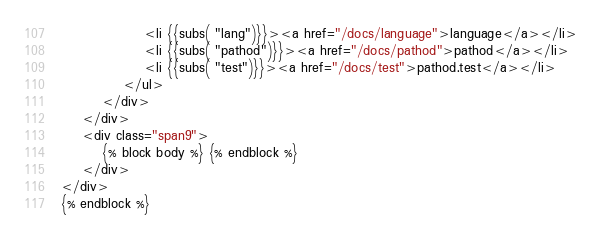<code> <loc_0><loc_0><loc_500><loc_500><_HTML_>                <li {{subs( "lang")}}><a href="/docs/language">language</a></li>
                <li {{subs( "pathod")}}><a href="/docs/pathod">pathod</a></li>
                <li {{subs( "test")}}><a href="/docs/test">pathod.test</a></li>
            </ul>
        </div>
    </div>
    <div class="span9">
        {% block body %} {% endblock %}
    </div>
</div>
{% endblock %}
</code> 